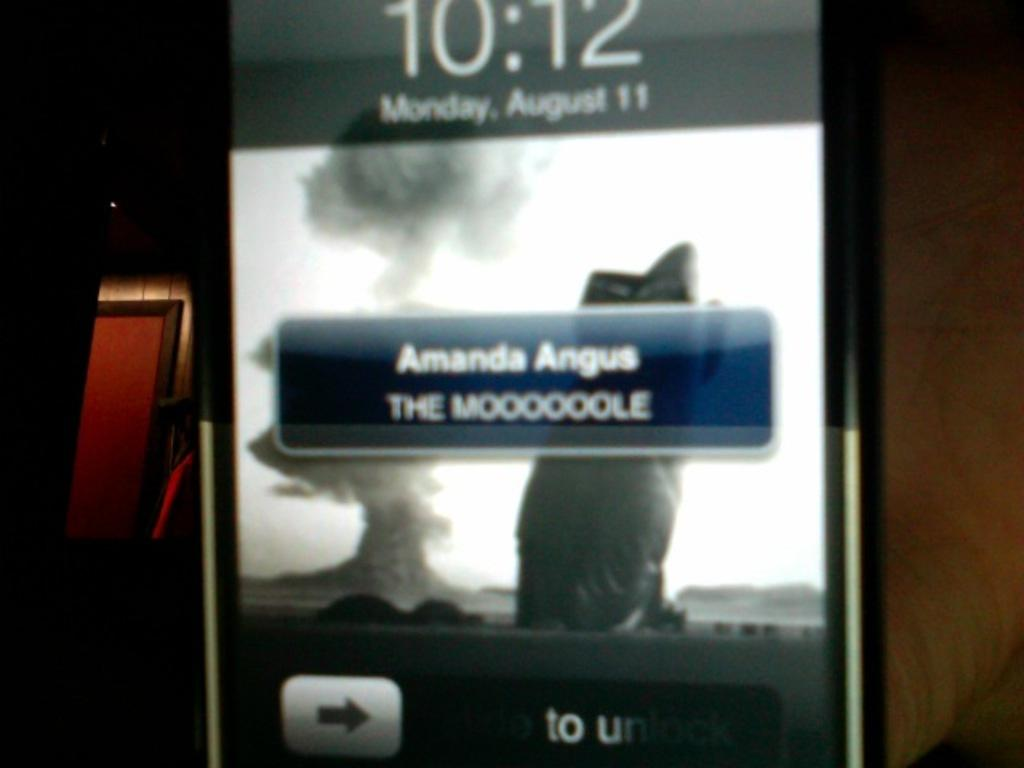<image>
Describe the image concisely. Cellphone screen that has the time at 10:12 and a message from Amanda. 